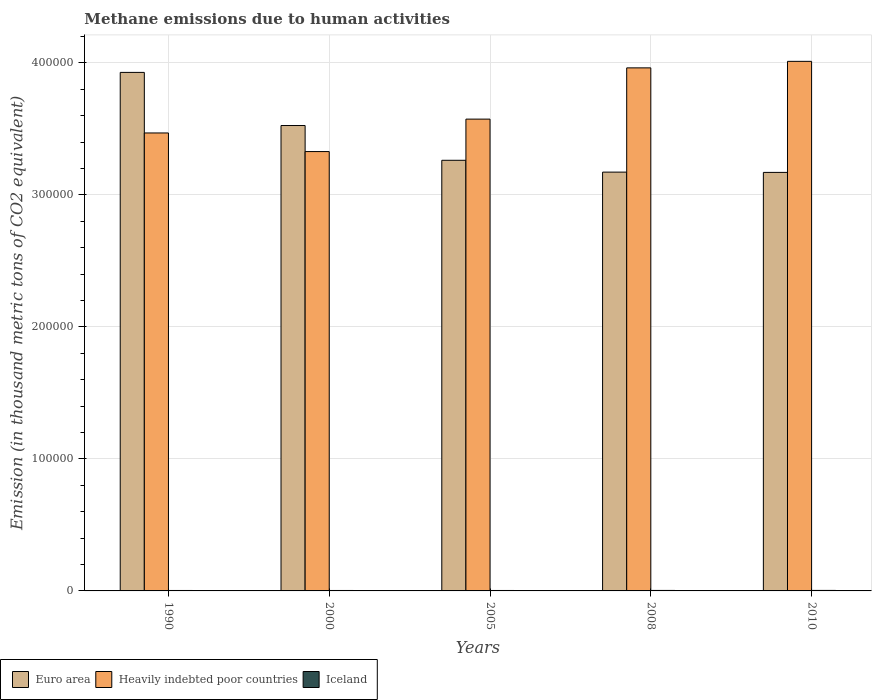How many groups of bars are there?
Provide a succinct answer. 5. Are the number of bars per tick equal to the number of legend labels?
Ensure brevity in your answer.  Yes. Are the number of bars on each tick of the X-axis equal?
Keep it short and to the point. Yes. How many bars are there on the 5th tick from the left?
Make the answer very short. 3. How many bars are there on the 2nd tick from the right?
Your response must be concise. 3. In how many cases, is the number of bars for a given year not equal to the number of legend labels?
Offer a terse response. 0. What is the amount of methane emitted in Euro area in 2000?
Provide a short and direct response. 3.53e+05. Across all years, what is the maximum amount of methane emitted in Euro area?
Make the answer very short. 3.93e+05. Across all years, what is the minimum amount of methane emitted in Euro area?
Provide a short and direct response. 3.17e+05. In which year was the amount of methane emitted in Heavily indebted poor countries maximum?
Provide a succinct answer. 2010. In which year was the amount of methane emitted in Heavily indebted poor countries minimum?
Provide a short and direct response. 2000. What is the total amount of methane emitted in Euro area in the graph?
Provide a short and direct response. 1.71e+06. What is the difference between the amount of methane emitted in Iceland in 1990 and that in 2008?
Make the answer very short. -25.5. What is the difference between the amount of methane emitted in Iceland in 2008 and the amount of methane emitted in Heavily indebted poor countries in 2005?
Make the answer very short. -3.57e+05. What is the average amount of methane emitted in Iceland per year?
Make the answer very short. 352.92. In the year 2010, what is the difference between the amount of methane emitted in Iceland and amount of methane emitted in Euro area?
Give a very brief answer. -3.17e+05. What is the ratio of the amount of methane emitted in Heavily indebted poor countries in 2008 to that in 2010?
Keep it short and to the point. 0.99. Is the difference between the amount of methane emitted in Iceland in 1990 and 2010 greater than the difference between the amount of methane emitted in Euro area in 1990 and 2010?
Your answer should be very brief. No. What is the difference between the highest and the second highest amount of methane emitted in Iceland?
Provide a succinct answer. 16.1. What is the difference between the highest and the lowest amount of methane emitted in Iceland?
Provide a succinct answer. 47.4. In how many years, is the amount of methane emitted in Euro area greater than the average amount of methane emitted in Euro area taken over all years?
Your answer should be compact. 2. What does the 2nd bar from the left in 1990 represents?
Your response must be concise. Heavily indebted poor countries. What does the 1st bar from the right in 2005 represents?
Keep it short and to the point. Iceland. Is it the case that in every year, the sum of the amount of methane emitted in Iceland and amount of methane emitted in Heavily indebted poor countries is greater than the amount of methane emitted in Euro area?
Keep it short and to the point. No. How many bars are there?
Offer a terse response. 15. Are the values on the major ticks of Y-axis written in scientific E-notation?
Provide a succinct answer. No. Does the graph contain any zero values?
Offer a terse response. No. How are the legend labels stacked?
Provide a short and direct response. Horizontal. What is the title of the graph?
Offer a very short reply. Methane emissions due to human activities. Does "Sao Tome and Principe" appear as one of the legend labels in the graph?
Your response must be concise. No. What is the label or title of the Y-axis?
Ensure brevity in your answer.  Emission (in thousand metric tons of CO2 equivalent). What is the Emission (in thousand metric tons of CO2 equivalent) in Euro area in 1990?
Offer a very short reply. 3.93e+05. What is the Emission (in thousand metric tons of CO2 equivalent) of Heavily indebted poor countries in 1990?
Provide a short and direct response. 3.47e+05. What is the Emission (in thousand metric tons of CO2 equivalent) in Iceland in 1990?
Offer a very short reply. 341.7. What is the Emission (in thousand metric tons of CO2 equivalent) of Euro area in 2000?
Offer a terse response. 3.53e+05. What is the Emission (in thousand metric tons of CO2 equivalent) of Heavily indebted poor countries in 2000?
Give a very brief answer. 3.33e+05. What is the Emission (in thousand metric tons of CO2 equivalent) in Iceland in 2000?
Keep it short and to the point. 336.5. What is the Emission (in thousand metric tons of CO2 equivalent) of Euro area in 2005?
Your response must be concise. 3.26e+05. What is the Emission (in thousand metric tons of CO2 equivalent) of Heavily indebted poor countries in 2005?
Ensure brevity in your answer.  3.57e+05. What is the Emission (in thousand metric tons of CO2 equivalent) in Iceland in 2005?
Make the answer very short. 335.9. What is the Emission (in thousand metric tons of CO2 equivalent) in Euro area in 2008?
Provide a succinct answer. 3.17e+05. What is the Emission (in thousand metric tons of CO2 equivalent) in Heavily indebted poor countries in 2008?
Give a very brief answer. 3.96e+05. What is the Emission (in thousand metric tons of CO2 equivalent) of Iceland in 2008?
Make the answer very short. 367.2. What is the Emission (in thousand metric tons of CO2 equivalent) of Euro area in 2010?
Provide a short and direct response. 3.17e+05. What is the Emission (in thousand metric tons of CO2 equivalent) in Heavily indebted poor countries in 2010?
Your response must be concise. 4.01e+05. What is the Emission (in thousand metric tons of CO2 equivalent) of Iceland in 2010?
Your answer should be compact. 383.3. Across all years, what is the maximum Emission (in thousand metric tons of CO2 equivalent) in Euro area?
Your response must be concise. 3.93e+05. Across all years, what is the maximum Emission (in thousand metric tons of CO2 equivalent) in Heavily indebted poor countries?
Provide a short and direct response. 4.01e+05. Across all years, what is the maximum Emission (in thousand metric tons of CO2 equivalent) of Iceland?
Keep it short and to the point. 383.3. Across all years, what is the minimum Emission (in thousand metric tons of CO2 equivalent) in Euro area?
Your answer should be very brief. 3.17e+05. Across all years, what is the minimum Emission (in thousand metric tons of CO2 equivalent) in Heavily indebted poor countries?
Offer a terse response. 3.33e+05. Across all years, what is the minimum Emission (in thousand metric tons of CO2 equivalent) of Iceland?
Provide a short and direct response. 335.9. What is the total Emission (in thousand metric tons of CO2 equivalent) in Euro area in the graph?
Ensure brevity in your answer.  1.71e+06. What is the total Emission (in thousand metric tons of CO2 equivalent) of Heavily indebted poor countries in the graph?
Provide a succinct answer. 1.83e+06. What is the total Emission (in thousand metric tons of CO2 equivalent) of Iceland in the graph?
Your answer should be very brief. 1764.6. What is the difference between the Emission (in thousand metric tons of CO2 equivalent) of Euro area in 1990 and that in 2000?
Give a very brief answer. 4.02e+04. What is the difference between the Emission (in thousand metric tons of CO2 equivalent) of Heavily indebted poor countries in 1990 and that in 2000?
Your answer should be compact. 1.41e+04. What is the difference between the Emission (in thousand metric tons of CO2 equivalent) in Iceland in 1990 and that in 2000?
Make the answer very short. 5.2. What is the difference between the Emission (in thousand metric tons of CO2 equivalent) of Euro area in 1990 and that in 2005?
Provide a short and direct response. 6.66e+04. What is the difference between the Emission (in thousand metric tons of CO2 equivalent) in Heavily indebted poor countries in 1990 and that in 2005?
Provide a succinct answer. -1.05e+04. What is the difference between the Emission (in thousand metric tons of CO2 equivalent) in Iceland in 1990 and that in 2005?
Provide a succinct answer. 5.8. What is the difference between the Emission (in thousand metric tons of CO2 equivalent) of Euro area in 1990 and that in 2008?
Offer a very short reply. 7.55e+04. What is the difference between the Emission (in thousand metric tons of CO2 equivalent) of Heavily indebted poor countries in 1990 and that in 2008?
Offer a terse response. -4.93e+04. What is the difference between the Emission (in thousand metric tons of CO2 equivalent) of Iceland in 1990 and that in 2008?
Offer a terse response. -25.5. What is the difference between the Emission (in thousand metric tons of CO2 equivalent) in Euro area in 1990 and that in 2010?
Make the answer very short. 7.58e+04. What is the difference between the Emission (in thousand metric tons of CO2 equivalent) in Heavily indebted poor countries in 1990 and that in 2010?
Ensure brevity in your answer.  -5.42e+04. What is the difference between the Emission (in thousand metric tons of CO2 equivalent) of Iceland in 1990 and that in 2010?
Your response must be concise. -41.6. What is the difference between the Emission (in thousand metric tons of CO2 equivalent) of Euro area in 2000 and that in 2005?
Keep it short and to the point. 2.63e+04. What is the difference between the Emission (in thousand metric tons of CO2 equivalent) of Heavily indebted poor countries in 2000 and that in 2005?
Your response must be concise. -2.46e+04. What is the difference between the Emission (in thousand metric tons of CO2 equivalent) of Euro area in 2000 and that in 2008?
Give a very brief answer. 3.53e+04. What is the difference between the Emission (in thousand metric tons of CO2 equivalent) of Heavily indebted poor countries in 2000 and that in 2008?
Ensure brevity in your answer.  -6.34e+04. What is the difference between the Emission (in thousand metric tons of CO2 equivalent) of Iceland in 2000 and that in 2008?
Offer a very short reply. -30.7. What is the difference between the Emission (in thousand metric tons of CO2 equivalent) in Euro area in 2000 and that in 2010?
Provide a short and direct response. 3.55e+04. What is the difference between the Emission (in thousand metric tons of CO2 equivalent) of Heavily indebted poor countries in 2000 and that in 2010?
Your answer should be very brief. -6.83e+04. What is the difference between the Emission (in thousand metric tons of CO2 equivalent) of Iceland in 2000 and that in 2010?
Ensure brevity in your answer.  -46.8. What is the difference between the Emission (in thousand metric tons of CO2 equivalent) of Euro area in 2005 and that in 2008?
Give a very brief answer. 8960.4. What is the difference between the Emission (in thousand metric tons of CO2 equivalent) in Heavily indebted poor countries in 2005 and that in 2008?
Your response must be concise. -3.88e+04. What is the difference between the Emission (in thousand metric tons of CO2 equivalent) in Iceland in 2005 and that in 2008?
Give a very brief answer. -31.3. What is the difference between the Emission (in thousand metric tons of CO2 equivalent) in Euro area in 2005 and that in 2010?
Your answer should be very brief. 9172.4. What is the difference between the Emission (in thousand metric tons of CO2 equivalent) in Heavily indebted poor countries in 2005 and that in 2010?
Ensure brevity in your answer.  -4.38e+04. What is the difference between the Emission (in thousand metric tons of CO2 equivalent) in Iceland in 2005 and that in 2010?
Make the answer very short. -47.4. What is the difference between the Emission (in thousand metric tons of CO2 equivalent) in Euro area in 2008 and that in 2010?
Keep it short and to the point. 212. What is the difference between the Emission (in thousand metric tons of CO2 equivalent) in Heavily indebted poor countries in 2008 and that in 2010?
Give a very brief answer. -4939.1. What is the difference between the Emission (in thousand metric tons of CO2 equivalent) in Iceland in 2008 and that in 2010?
Keep it short and to the point. -16.1. What is the difference between the Emission (in thousand metric tons of CO2 equivalent) in Euro area in 1990 and the Emission (in thousand metric tons of CO2 equivalent) in Heavily indebted poor countries in 2000?
Your answer should be compact. 6.00e+04. What is the difference between the Emission (in thousand metric tons of CO2 equivalent) of Euro area in 1990 and the Emission (in thousand metric tons of CO2 equivalent) of Iceland in 2000?
Provide a short and direct response. 3.92e+05. What is the difference between the Emission (in thousand metric tons of CO2 equivalent) in Heavily indebted poor countries in 1990 and the Emission (in thousand metric tons of CO2 equivalent) in Iceland in 2000?
Provide a succinct answer. 3.47e+05. What is the difference between the Emission (in thousand metric tons of CO2 equivalent) in Euro area in 1990 and the Emission (in thousand metric tons of CO2 equivalent) in Heavily indebted poor countries in 2005?
Ensure brevity in your answer.  3.54e+04. What is the difference between the Emission (in thousand metric tons of CO2 equivalent) of Euro area in 1990 and the Emission (in thousand metric tons of CO2 equivalent) of Iceland in 2005?
Your answer should be compact. 3.92e+05. What is the difference between the Emission (in thousand metric tons of CO2 equivalent) in Heavily indebted poor countries in 1990 and the Emission (in thousand metric tons of CO2 equivalent) in Iceland in 2005?
Keep it short and to the point. 3.47e+05. What is the difference between the Emission (in thousand metric tons of CO2 equivalent) of Euro area in 1990 and the Emission (in thousand metric tons of CO2 equivalent) of Heavily indebted poor countries in 2008?
Offer a terse response. -3426.9. What is the difference between the Emission (in thousand metric tons of CO2 equivalent) of Euro area in 1990 and the Emission (in thousand metric tons of CO2 equivalent) of Iceland in 2008?
Your response must be concise. 3.92e+05. What is the difference between the Emission (in thousand metric tons of CO2 equivalent) of Heavily indebted poor countries in 1990 and the Emission (in thousand metric tons of CO2 equivalent) of Iceland in 2008?
Offer a terse response. 3.47e+05. What is the difference between the Emission (in thousand metric tons of CO2 equivalent) in Euro area in 1990 and the Emission (in thousand metric tons of CO2 equivalent) in Heavily indebted poor countries in 2010?
Offer a very short reply. -8366. What is the difference between the Emission (in thousand metric tons of CO2 equivalent) of Euro area in 1990 and the Emission (in thousand metric tons of CO2 equivalent) of Iceland in 2010?
Offer a very short reply. 3.92e+05. What is the difference between the Emission (in thousand metric tons of CO2 equivalent) in Heavily indebted poor countries in 1990 and the Emission (in thousand metric tons of CO2 equivalent) in Iceland in 2010?
Provide a succinct answer. 3.47e+05. What is the difference between the Emission (in thousand metric tons of CO2 equivalent) of Euro area in 2000 and the Emission (in thousand metric tons of CO2 equivalent) of Heavily indebted poor countries in 2005?
Offer a very short reply. -4857.8. What is the difference between the Emission (in thousand metric tons of CO2 equivalent) of Euro area in 2000 and the Emission (in thousand metric tons of CO2 equivalent) of Iceland in 2005?
Your answer should be compact. 3.52e+05. What is the difference between the Emission (in thousand metric tons of CO2 equivalent) in Heavily indebted poor countries in 2000 and the Emission (in thousand metric tons of CO2 equivalent) in Iceland in 2005?
Provide a succinct answer. 3.32e+05. What is the difference between the Emission (in thousand metric tons of CO2 equivalent) in Euro area in 2000 and the Emission (in thousand metric tons of CO2 equivalent) in Heavily indebted poor countries in 2008?
Keep it short and to the point. -4.37e+04. What is the difference between the Emission (in thousand metric tons of CO2 equivalent) of Euro area in 2000 and the Emission (in thousand metric tons of CO2 equivalent) of Iceland in 2008?
Ensure brevity in your answer.  3.52e+05. What is the difference between the Emission (in thousand metric tons of CO2 equivalent) of Heavily indebted poor countries in 2000 and the Emission (in thousand metric tons of CO2 equivalent) of Iceland in 2008?
Make the answer very short. 3.32e+05. What is the difference between the Emission (in thousand metric tons of CO2 equivalent) of Euro area in 2000 and the Emission (in thousand metric tons of CO2 equivalent) of Heavily indebted poor countries in 2010?
Your response must be concise. -4.86e+04. What is the difference between the Emission (in thousand metric tons of CO2 equivalent) of Euro area in 2000 and the Emission (in thousand metric tons of CO2 equivalent) of Iceland in 2010?
Your answer should be compact. 3.52e+05. What is the difference between the Emission (in thousand metric tons of CO2 equivalent) of Heavily indebted poor countries in 2000 and the Emission (in thousand metric tons of CO2 equivalent) of Iceland in 2010?
Your response must be concise. 3.32e+05. What is the difference between the Emission (in thousand metric tons of CO2 equivalent) in Euro area in 2005 and the Emission (in thousand metric tons of CO2 equivalent) in Heavily indebted poor countries in 2008?
Ensure brevity in your answer.  -7.00e+04. What is the difference between the Emission (in thousand metric tons of CO2 equivalent) in Euro area in 2005 and the Emission (in thousand metric tons of CO2 equivalent) in Iceland in 2008?
Your answer should be very brief. 3.26e+05. What is the difference between the Emission (in thousand metric tons of CO2 equivalent) in Heavily indebted poor countries in 2005 and the Emission (in thousand metric tons of CO2 equivalent) in Iceland in 2008?
Provide a succinct answer. 3.57e+05. What is the difference between the Emission (in thousand metric tons of CO2 equivalent) of Euro area in 2005 and the Emission (in thousand metric tons of CO2 equivalent) of Heavily indebted poor countries in 2010?
Your response must be concise. -7.50e+04. What is the difference between the Emission (in thousand metric tons of CO2 equivalent) of Euro area in 2005 and the Emission (in thousand metric tons of CO2 equivalent) of Iceland in 2010?
Offer a very short reply. 3.26e+05. What is the difference between the Emission (in thousand metric tons of CO2 equivalent) of Heavily indebted poor countries in 2005 and the Emission (in thousand metric tons of CO2 equivalent) of Iceland in 2010?
Ensure brevity in your answer.  3.57e+05. What is the difference between the Emission (in thousand metric tons of CO2 equivalent) of Euro area in 2008 and the Emission (in thousand metric tons of CO2 equivalent) of Heavily indebted poor countries in 2010?
Give a very brief answer. -8.39e+04. What is the difference between the Emission (in thousand metric tons of CO2 equivalent) of Euro area in 2008 and the Emission (in thousand metric tons of CO2 equivalent) of Iceland in 2010?
Offer a terse response. 3.17e+05. What is the difference between the Emission (in thousand metric tons of CO2 equivalent) of Heavily indebted poor countries in 2008 and the Emission (in thousand metric tons of CO2 equivalent) of Iceland in 2010?
Give a very brief answer. 3.96e+05. What is the average Emission (in thousand metric tons of CO2 equivalent) of Euro area per year?
Make the answer very short. 3.41e+05. What is the average Emission (in thousand metric tons of CO2 equivalent) of Heavily indebted poor countries per year?
Offer a very short reply. 3.67e+05. What is the average Emission (in thousand metric tons of CO2 equivalent) of Iceland per year?
Provide a succinct answer. 352.92. In the year 1990, what is the difference between the Emission (in thousand metric tons of CO2 equivalent) of Euro area and Emission (in thousand metric tons of CO2 equivalent) of Heavily indebted poor countries?
Make the answer very short. 4.59e+04. In the year 1990, what is the difference between the Emission (in thousand metric tons of CO2 equivalent) of Euro area and Emission (in thousand metric tons of CO2 equivalent) of Iceland?
Provide a succinct answer. 3.92e+05. In the year 1990, what is the difference between the Emission (in thousand metric tons of CO2 equivalent) of Heavily indebted poor countries and Emission (in thousand metric tons of CO2 equivalent) of Iceland?
Your answer should be very brief. 3.47e+05. In the year 2000, what is the difference between the Emission (in thousand metric tons of CO2 equivalent) in Euro area and Emission (in thousand metric tons of CO2 equivalent) in Heavily indebted poor countries?
Provide a succinct answer. 1.97e+04. In the year 2000, what is the difference between the Emission (in thousand metric tons of CO2 equivalent) in Euro area and Emission (in thousand metric tons of CO2 equivalent) in Iceland?
Your response must be concise. 3.52e+05. In the year 2000, what is the difference between the Emission (in thousand metric tons of CO2 equivalent) in Heavily indebted poor countries and Emission (in thousand metric tons of CO2 equivalent) in Iceland?
Give a very brief answer. 3.32e+05. In the year 2005, what is the difference between the Emission (in thousand metric tons of CO2 equivalent) in Euro area and Emission (in thousand metric tons of CO2 equivalent) in Heavily indebted poor countries?
Give a very brief answer. -3.12e+04. In the year 2005, what is the difference between the Emission (in thousand metric tons of CO2 equivalent) in Euro area and Emission (in thousand metric tons of CO2 equivalent) in Iceland?
Offer a very short reply. 3.26e+05. In the year 2005, what is the difference between the Emission (in thousand metric tons of CO2 equivalent) in Heavily indebted poor countries and Emission (in thousand metric tons of CO2 equivalent) in Iceland?
Your answer should be compact. 3.57e+05. In the year 2008, what is the difference between the Emission (in thousand metric tons of CO2 equivalent) of Euro area and Emission (in thousand metric tons of CO2 equivalent) of Heavily indebted poor countries?
Provide a succinct answer. -7.90e+04. In the year 2008, what is the difference between the Emission (in thousand metric tons of CO2 equivalent) in Euro area and Emission (in thousand metric tons of CO2 equivalent) in Iceland?
Provide a short and direct response. 3.17e+05. In the year 2008, what is the difference between the Emission (in thousand metric tons of CO2 equivalent) in Heavily indebted poor countries and Emission (in thousand metric tons of CO2 equivalent) in Iceland?
Provide a short and direct response. 3.96e+05. In the year 2010, what is the difference between the Emission (in thousand metric tons of CO2 equivalent) of Euro area and Emission (in thousand metric tons of CO2 equivalent) of Heavily indebted poor countries?
Provide a succinct answer. -8.41e+04. In the year 2010, what is the difference between the Emission (in thousand metric tons of CO2 equivalent) in Euro area and Emission (in thousand metric tons of CO2 equivalent) in Iceland?
Provide a short and direct response. 3.17e+05. In the year 2010, what is the difference between the Emission (in thousand metric tons of CO2 equivalent) in Heavily indebted poor countries and Emission (in thousand metric tons of CO2 equivalent) in Iceland?
Your answer should be very brief. 4.01e+05. What is the ratio of the Emission (in thousand metric tons of CO2 equivalent) of Euro area in 1990 to that in 2000?
Make the answer very short. 1.11. What is the ratio of the Emission (in thousand metric tons of CO2 equivalent) of Heavily indebted poor countries in 1990 to that in 2000?
Give a very brief answer. 1.04. What is the ratio of the Emission (in thousand metric tons of CO2 equivalent) of Iceland in 1990 to that in 2000?
Give a very brief answer. 1.02. What is the ratio of the Emission (in thousand metric tons of CO2 equivalent) of Euro area in 1990 to that in 2005?
Offer a terse response. 1.2. What is the ratio of the Emission (in thousand metric tons of CO2 equivalent) in Heavily indebted poor countries in 1990 to that in 2005?
Provide a short and direct response. 0.97. What is the ratio of the Emission (in thousand metric tons of CO2 equivalent) of Iceland in 1990 to that in 2005?
Offer a very short reply. 1.02. What is the ratio of the Emission (in thousand metric tons of CO2 equivalent) in Euro area in 1990 to that in 2008?
Ensure brevity in your answer.  1.24. What is the ratio of the Emission (in thousand metric tons of CO2 equivalent) in Heavily indebted poor countries in 1990 to that in 2008?
Provide a short and direct response. 0.88. What is the ratio of the Emission (in thousand metric tons of CO2 equivalent) in Iceland in 1990 to that in 2008?
Your response must be concise. 0.93. What is the ratio of the Emission (in thousand metric tons of CO2 equivalent) in Euro area in 1990 to that in 2010?
Provide a short and direct response. 1.24. What is the ratio of the Emission (in thousand metric tons of CO2 equivalent) in Heavily indebted poor countries in 1990 to that in 2010?
Provide a succinct answer. 0.86. What is the ratio of the Emission (in thousand metric tons of CO2 equivalent) in Iceland in 1990 to that in 2010?
Your answer should be very brief. 0.89. What is the ratio of the Emission (in thousand metric tons of CO2 equivalent) in Euro area in 2000 to that in 2005?
Give a very brief answer. 1.08. What is the ratio of the Emission (in thousand metric tons of CO2 equivalent) of Heavily indebted poor countries in 2000 to that in 2005?
Offer a very short reply. 0.93. What is the ratio of the Emission (in thousand metric tons of CO2 equivalent) of Iceland in 2000 to that in 2005?
Keep it short and to the point. 1. What is the ratio of the Emission (in thousand metric tons of CO2 equivalent) in Euro area in 2000 to that in 2008?
Offer a very short reply. 1.11. What is the ratio of the Emission (in thousand metric tons of CO2 equivalent) in Heavily indebted poor countries in 2000 to that in 2008?
Make the answer very short. 0.84. What is the ratio of the Emission (in thousand metric tons of CO2 equivalent) of Iceland in 2000 to that in 2008?
Offer a very short reply. 0.92. What is the ratio of the Emission (in thousand metric tons of CO2 equivalent) in Euro area in 2000 to that in 2010?
Ensure brevity in your answer.  1.11. What is the ratio of the Emission (in thousand metric tons of CO2 equivalent) of Heavily indebted poor countries in 2000 to that in 2010?
Offer a terse response. 0.83. What is the ratio of the Emission (in thousand metric tons of CO2 equivalent) in Iceland in 2000 to that in 2010?
Your answer should be compact. 0.88. What is the ratio of the Emission (in thousand metric tons of CO2 equivalent) in Euro area in 2005 to that in 2008?
Keep it short and to the point. 1.03. What is the ratio of the Emission (in thousand metric tons of CO2 equivalent) of Heavily indebted poor countries in 2005 to that in 2008?
Ensure brevity in your answer.  0.9. What is the ratio of the Emission (in thousand metric tons of CO2 equivalent) of Iceland in 2005 to that in 2008?
Keep it short and to the point. 0.91. What is the ratio of the Emission (in thousand metric tons of CO2 equivalent) of Euro area in 2005 to that in 2010?
Provide a succinct answer. 1.03. What is the ratio of the Emission (in thousand metric tons of CO2 equivalent) of Heavily indebted poor countries in 2005 to that in 2010?
Provide a short and direct response. 0.89. What is the ratio of the Emission (in thousand metric tons of CO2 equivalent) of Iceland in 2005 to that in 2010?
Your response must be concise. 0.88. What is the ratio of the Emission (in thousand metric tons of CO2 equivalent) of Euro area in 2008 to that in 2010?
Ensure brevity in your answer.  1. What is the ratio of the Emission (in thousand metric tons of CO2 equivalent) in Iceland in 2008 to that in 2010?
Keep it short and to the point. 0.96. What is the difference between the highest and the second highest Emission (in thousand metric tons of CO2 equivalent) in Euro area?
Keep it short and to the point. 4.02e+04. What is the difference between the highest and the second highest Emission (in thousand metric tons of CO2 equivalent) of Heavily indebted poor countries?
Your answer should be compact. 4939.1. What is the difference between the highest and the second highest Emission (in thousand metric tons of CO2 equivalent) in Iceland?
Your answer should be compact. 16.1. What is the difference between the highest and the lowest Emission (in thousand metric tons of CO2 equivalent) in Euro area?
Offer a very short reply. 7.58e+04. What is the difference between the highest and the lowest Emission (in thousand metric tons of CO2 equivalent) of Heavily indebted poor countries?
Your answer should be very brief. 6.83e+04. What is the difference between the highest and the lowest Emission (in thousand metric tons of CO2 equivalent) in Iceland?
Keep it short and to the point. 47.4. 